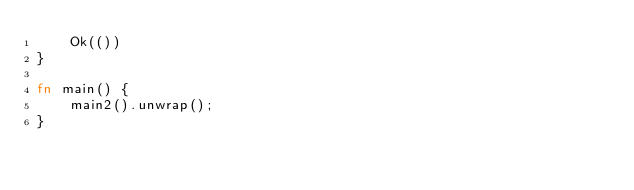<code> <loc_0><loc_0><loc_500><loc_500><_Rust_>    Ok(())
}

fn main() {
    main2().unwrap();
}
</code> 